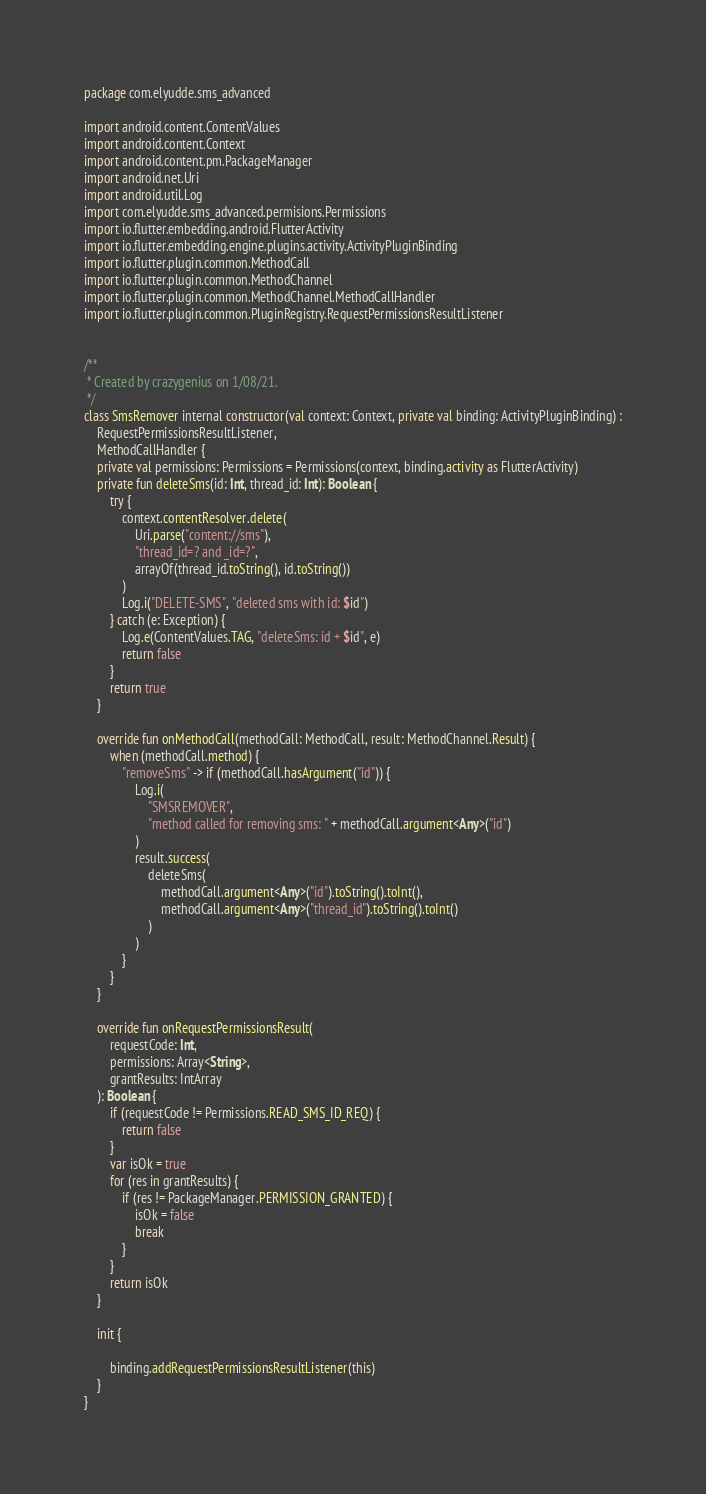Convert code to text. <code><loc_0><loc_0><loc_500><loc_500><_Kotlin_>package com.elyudde.sms_advanced

import android.content.ContentValues
import android.content.Context
import android.content.pm.PackageManager
import android.net.Uri
import android.util.Log
import com.elyudde.sms_advanced.permisions.Permissions
import io.flutter.embedding.android.FlutterActivity
import io.flutter.embedding.engine.plugins.activity.ActivityPluginBinding
import io.flutter.plugin.common.MethodCall
import io.flutter.plugin.common.MethodChannel
import io.flutter.plugin.common.MethodChannel.MethodCallHandler
import io.flutter.plugin.common.PluginRegistry.RequestPermissionsResultListener


/**
 * Created by crazygenius on 1/08/21.
 */
class SmsRemover internal constructor(val context: Context, private val binding: ActivityPluginBinding) :
    RequestPermissionsResultListener,
    MethodCallHandler {
    private val permissions: Permissions = Permissions(context, binding.activity as FlutterActivity)
    private fun deleteSms(id: Int, thread_id: Int): Boolean {
        try {
            context.contentResolver.delete(
                Uri.parse("content://sms"),
                "thread_id=? and _id=?",
                arrayOf(thread_id.toString(), id.toString())
            )
            Log.i("DELETE-SMS", "deleted sms with id: $id")
        } catch (e: Exception) {
            Log.e(ContentValues.TAG, "deleteSms: id + $id", e)
            return false
        }
        return true
    }

    override fun onMethodCall(methodCall: MethodCall, result: MethodChannel.Result) {
        when (methodCall.method) {
            "removeSms" -> if (methodCall.hasArgument("id")) {
                Log.i(
                    "SMSREMOVER",
                    "method called for removing sms: " + methodCall.argument<Any>("id")
                )
                result.success(
                    deleteSms(
                        methodCall.argument<Any>("id").toString().toInt(),
                        methodCall.argument<Any>("thread_id").toString().toInt()
                    )
                )
            }
        }
    }

    override fun onRequestPermissionsResult(
        requestCode: Int,
        permissions: Array<String>,
        grantResults: IntArray
    ): Boolean {
        if (requestCode != Permissions.READ_SMS_ID_REQ) {
            return false
        }
        var isOk = true
        for (res in grantResults) {
            if (res != PackageManager.PERMISSION_GRANTED) {
                isOk = false
                break
            }
        }
        return isOk
    }

    init {

        binding.addRequestPermissionsResultListener(this)
    }
}


</code> 